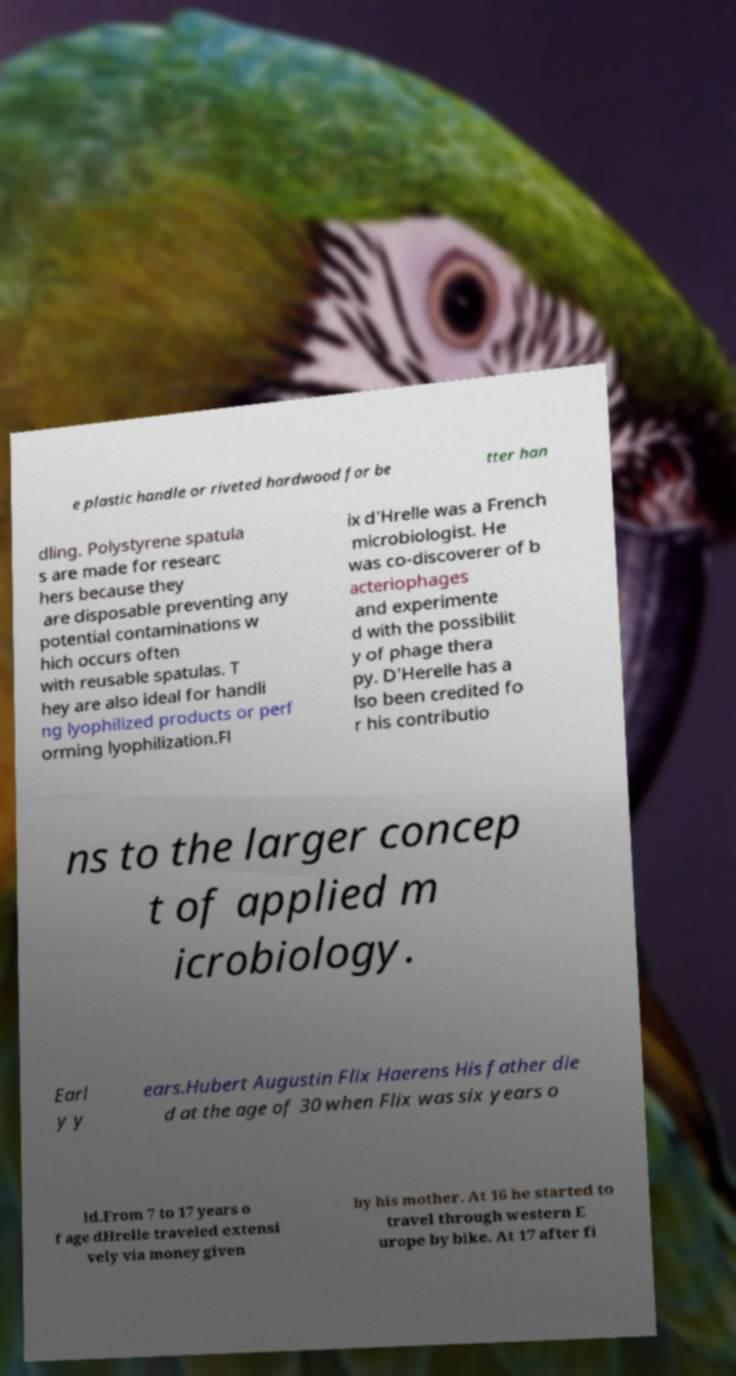There's text embedded in this image that I need extracted. Can you transcribe it verbatim? e plastic handle or riveted hardwood for be tter han dling. Polystyrene spatula s are made for researc hers because they are disposable preventing any potential contaminations w hich occurs often with reusable spatulas. T hey are also ideal for handli ng lyophilized products or perf orming lyophilization.Fl ix d'Hrelle was a French microbiologist. He was co-discoverer of b acteriophages and experimente d with the possibilit y of phage thera py. D'Herelle has a lso been credited fo r his contributio ns to the larger concep t of applied m icrobiology. Earl y y ears.Hubert Augustin Flix Haerens His father die d at the age of 30 when Flix was six years o ld.From 7 to 17 years o f age dHrelle traveled extensi vely via money given by his mother. At 16 he started to travel through western E urope by bike. At 17 after fi 